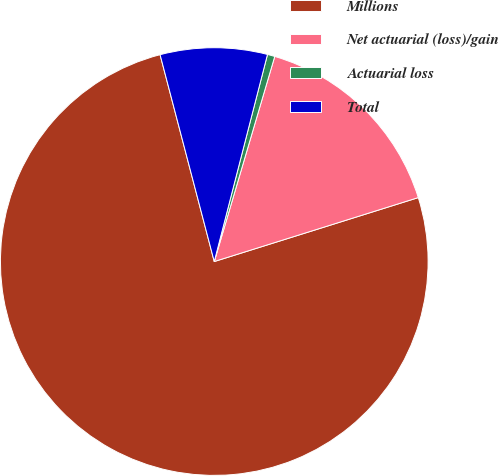<chart> <loc_0><loc_0><loc_500><loc_500><pie_chart><fcel>Millions<fcel>Net actuarial (loss)/gain<fcel>Actuarial loss<fcel>Total<nl><fcel>75.75%<fcel>15.6%<fcel>0.56%<fcel>8.08%<nl></chart> 